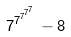<formula> <loc_0><loc_0><loc_500><loc_500>7 ^ { 7 ^ { 7 ^ { 7 ^ { 7 } } } } - 8</formula> 